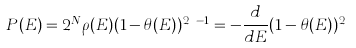<formula> <loc_0><loc_0><loc_500><loc_500>P ( E ) = 2 ^ { N } \rho ( E ) ( 1 - \theta ( E ) ) ^ { 2 ^ { N } - 1 } = - \frac { d } { d E } ( 1 - \theta ( E ) ) ^ { 2 ^ { N } }</formula> 